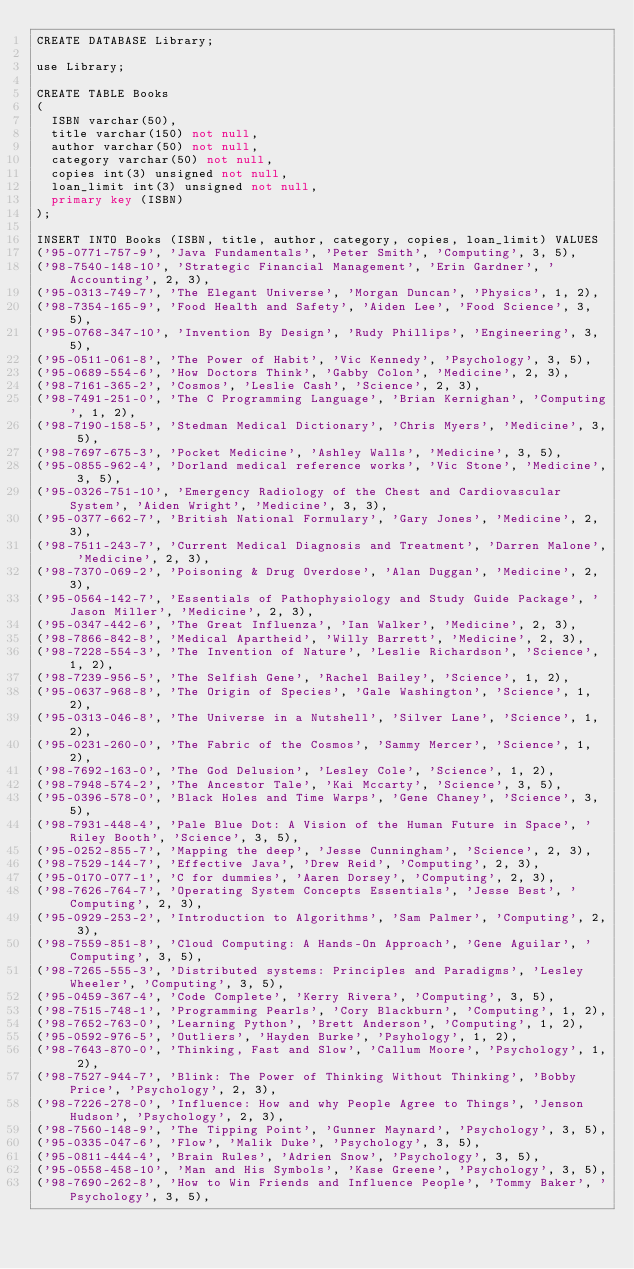Convert code to text. <code><loc_0><loc_0><loc_500><loc_500><_SQL_>CREATE DATABASE Library;

use Library;

CREATE TABLE Books 
(  
	ISBN varchar(50),
	title varchar(150) not null,
	author varchar(50) not null,
	category varchar(50) not null,
	copies int(3) unsigned not null,
	loan_limit int(3) unsigned not null,
	primary key (ISBN)
);

INSERT INTO Books (ISBN, title, author, category, copies, loan_limit) VALUES
('95-0771-757-9', 'Java Fundamentals', 'Peter Smith', 'Computing', 3, 5),
('98-7540-148-10', 'Strategic Financial Management', 'Erin Gardner', 'Accounting', 2, 3),
('95-0313-749-7', 'The Elegant Universe', 'Morgan Duncan', 'Physics', 1, 2),
('98-7354-165-9', 'Food Health and Safety', 'Aiden Lee', 'Food Science', 3, 5),
('95-0768-347-10', 'Invention By Design', 'Rudy Phillips', 'Engineering', 3, 5),
('95-0511-061-8', 'The Power of Habit', 'Vic Kennedy', 'Psychology', 3, 5),
('95-0689-554-6', 'How Doctors Think', 'Gabby Colon', 'Medicine', 2, 3),
('98-7161-365-2', 'Cosmos', 'Leslie Cash', 'Science', 2, 3),
('98-7491-251-0', 'The C Programming Language', 'Brian Kernighan', 'Computing', 1, 2),
('98-7190-158-5', 'Stedman Medical Dictionary', 'Chris Myers', 'Medicine', 3, 5),
('98-7697-675-3', 'Pocket Medicine', 'Ashley Walls', 'Medicine', 3, 5),
('95-0855-962-4', 'Dorland medical reference works', 'Vic Stone', 'Medicine', 3, 5),
('95-0326-751-10', 'Emergency Radiology of the Chest and Cardiovascular System', 'Aiden Wright', 'Medicine', 3, 3),
('95-0377-662-7', 'British National Formulary', 'Gary Jones', 'Medicine', 2, 3),
('98-7511-243-7', 'Current Medical Diagnosis and Treatment', 'Darren Malone', 'Medicine', 2, 3),
('98-7370-069-2', 'Poisoning & Drug Overdose', 'Alan Duggan', 'Medicine', 2, 3),
('95-0564-142-7', 'Essentials of Pathophysiology and Study Guide Package', 'Jason Miller', 'Medicine', 2, 3),
('95-0347-442-6', 'The Great Influenza', 'Ian Walker', 'Medicine', 2, 3),
('98-7866-842-8', 'Medical Apartheid', 'Willy Barrett', 'Medicine', 2, 3),
('98-7228-554-3', 'The Invention of Nature', 'Leslie Richardson', 'Science', 1, 2),
('98-7239-956-5', 'The Selfish Gene', 'Rachel Bailey', 'Science', 1, 2),
('95-0637-968-8', 'The Origin of Species', 'Gale Washington', 'Science', 1, 2),
('95-0313-046-8', 'The Universe in a Nutshell', 'Silver Lane', 'Science', 1, 2),
('95-0231-260-0', 'The Fabric of the Cosmos', 'Sammy Mercer', 'Science', 1, 2),
('98-7692-163-0', 'The God Delusion', 'Lesley Cole', 'Science', 1, 2),
('98-7948-574-2', 'The Ancestor Tale', 'Kai Mccarty', 'Science', 3, 5),
('95-0396-578-0', 'Black Holes and Time Warps', 'Gene Chaney', 'Science', 3, 5),
('98-7931-448-4', 'Pale Blue Dot: A Vision of the Human Future in Space', 'Riley Booth', 'Science', 3, 5),
('95-0252-855-7', 'Mapping the deep', 'Jesse Cunningham', 'Science', 2, 3),
('98-7529-144-7', 'Effective Java', 'Drew Reid', 'Computing', 2, 3),
('95-0170-077-1', 'C for dummies', 'Aaren Dorsey', 'Computing', 2, 3),
('98-7626-764-7', 'Operating System Concepts Essentials', 'Jesse Best', 'Computing', 2, 3),
('95-0929-253-2', 'Introduction to Algorithms', 'Sam Palmer', 'Computing', 2, 3),
('98-7559-851-8', 'Cloud Computing: A Hands-On Approach', 'Gene Aguilar', 'Computing', 3, 5),
('98-7265-555-3', 'Distributed systems: Principles and Paradigms', 'Lesley Wheeler', 'Computing', 3, 5),
('95-0459-367-4', 'Code Complete', 'Kerry Rivera', 'Computing', 3, 5),
('98-7515-748-1', 'Programming Pearls', 'Cory Blackburn', 'Computing', 1, 2),
('98-7652-763-0', 'Learning Python', 'Brett Anderson', 'Computing', 1, 2),
('95-0592-976-5', 'Outliers', 'Hayden Burke', 'Psyhology', 1, 2),
('98-7643-870-0', 'Thinking, Fast and Slow', 'Callum Moore', 'Psychology', 1, 2),
('98-7527-944-7', 'Blink: The Power of Thinking Without Thinking', 'Bobby Price', 'Psychology', 2, 3),
('98-7226-278-0', 'Influence: How and why People Agree to Things', 'Jenson Hudson', 'Psychology', 2, 3),
('98-7560-148-9', 'The Tipping Point', 'Gunner Maynard', 'Psychology', 3, 5),
('95-0335-047-6', 'Flow', 'Malik Duke', 'Psychology', 3, 5),
('95-0811-444-4', 'Brain Rules', 'Adrien Snow', 'Psychology', 3, 5),
('95-0558-458-10', 'Man and His Symbols', 'Kase Greene', 'Psychology', 3, 5),
('98-7690-262-8', 'How to Win Friends and Influence People', 'Tommy Baker', 'Psychology', 3, 5),</code> 